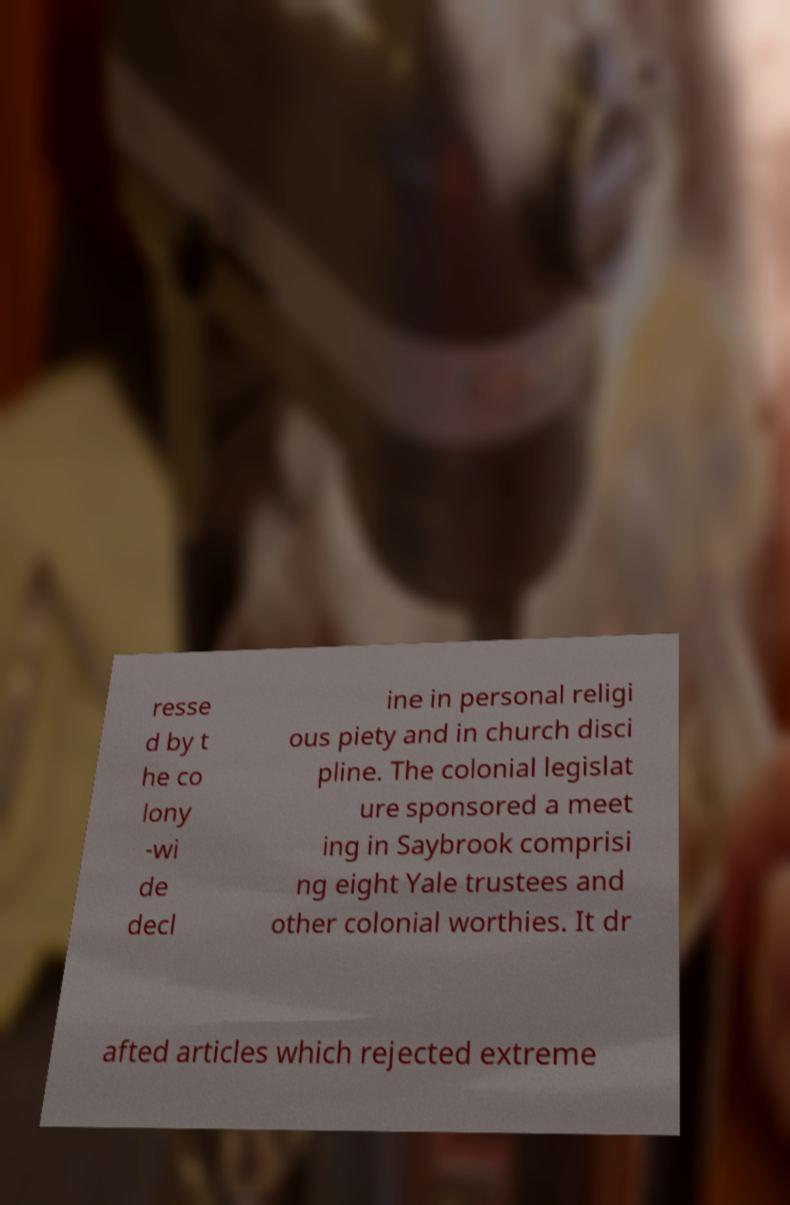Could you assist in decoding the text presented in this image and type it out clearly? resse d by t he co lony -wi de decl ine in personal religi ous piety and in church disci pline. The colonial legislat ure sponsored a meet ing in Saybrook comprisi ng eight Yale trustees and other colonial worthies. It dr afted articles which rejected extreme 